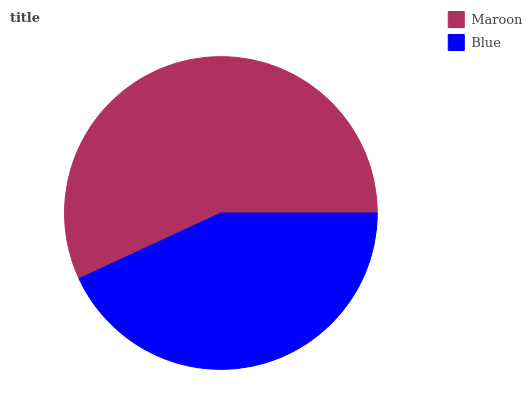Is Blue the minimum?
Answer yes or no. Yes. Is Maroon the maximum?
Answer yes or no. Yes. Is Blue the maximum?
Answer yes or no. No. Is Maroon greater than Blue?
Answer yes or no. Yes. Is Blue less than Maroon?
Answer yes or no. Yes. Is Blue greater than Maroon?
Answer yes or no. No. Is Maroon less than Blue?
Answer yes or no. No. Is Maroon the high median?
Answer yes or no. Yes. Is Blue the low median?
Answer yes or no. Yes. Is Blue the high median?
Answer yes or no. No. Is Maroon the low median?
Answer yes or no. No. 